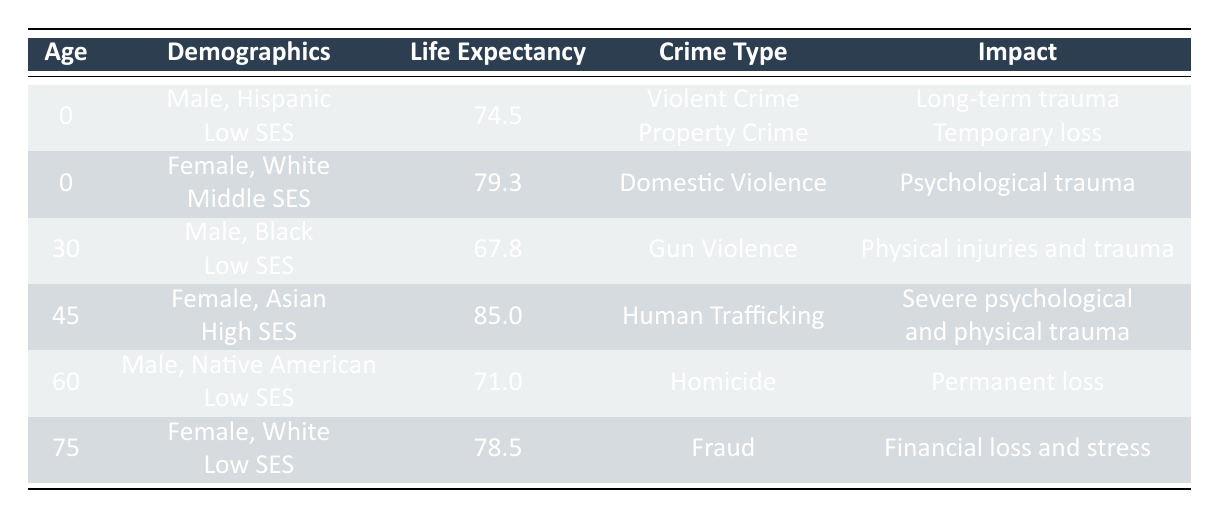What is the life expectancy for a 0-year-old male of Hispanic ethnicity from a low socioeconomic status? The table shows that for a 0-year-old male of Hispanic ethnicity with low socioeconomic status, the life expectancy is listed as 74.5 years.
Answer: 74.5 What type of crime did the 30-year-old male Black victim experience and what was its impact? The table indicates that the 30-year-old male Black victim experienced gun violence, which had a critical severity and resulted in physical injuries and trauma.
Answer: Gun violence; physical injuries and trauma Is the life expectancy of the 45-year-old female Asian victim higher or lower than 80 years? The life expectancy for the 45-year-old female Asian victim is 85.0 years, which is higher than 80 years. Thus, the answer is yes, it is higher.
Answer: Yes What is the combined life expectancy of the 60-year-old male Native American victim and the 0-year-old male Hispanic victim? The life expectancy for the 60-year-old male Native American is 71.0 years, and for the 0-year-old male Hispanic, it is 74.5 years. Adding these gives: 71.0 + 74.5 = 145.5 years.
Answer: 145.5 Did any of the victims listed in the table experience a crime categorized as fatal? According to the table, the 60-year-old male Native American victim experienced homicide, categorized as fatal. Therefore, the answer is yes.
Answer: Yes What is the average life expectancy of female victims in the table? The life expectancies of the female victims are 79.3 (0-year-old White), 85.0 (45-year-old Asian), and 78.5 (75-year-old White). The total is 79.3 + 85.0 + 78.5 = 242.8 years, and dividing by 3 gives an average life expectancy of 242.8 / 3 = 80.93 years.
Answer: 80.93 What type of crime did the 75-year-old female White victim experience and what was its severity? The 75-year-old female White victim experienced fraud, which is categorized as having moderate severity according to the table.
Answer: Fraud; moderate severity How many victims with low socioeconomic status have a life expectancy below 75 years? The victims with low socioeconomic status are the 0-year-old Hispanic male (74.5 years), the 30-year-old Black male (67.8 years), and the 60-year-old Native American male (71.0 years). Out of these, two have a life expectancy below 75 years (the 30-year-old and 60-year-old).
Answer: 2 